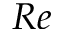<formula> <loc_0><loc_0><loc_500><loc_500>R e</formula> 